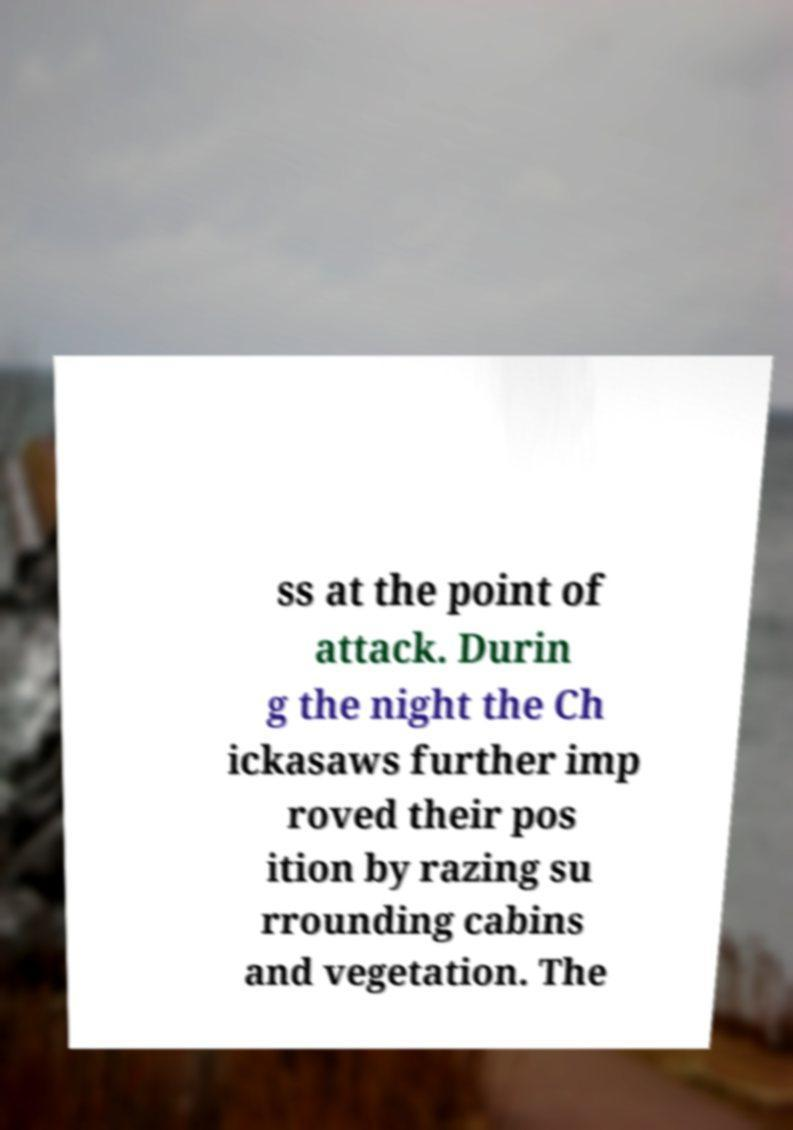Could you assist in decoding the text presented in this image and type it out clearly? ss at the point of attack. Durin g the night the Ch ickasaws further imp roved their pos ition by razing su rrounding cabins and vegetation. The 